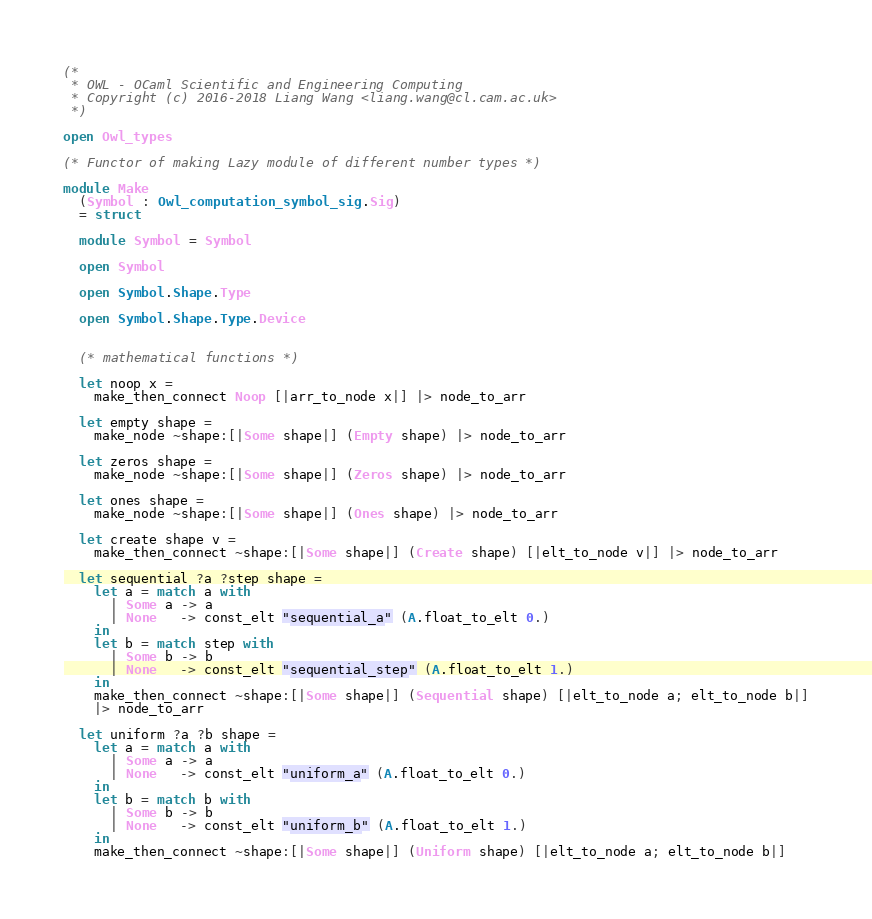<code> <loc_0><loc_0><loc_500><loc_500><_OCaml_>(*
 * OWL - OCaml Scientific and Engineering Computing
 * Copyright (c) 2016-2018 Liang Wang <liang.wang@cl.cam.ac.uk>
 *)

open Owl_types

(* Functor of making Lazy module of different number types *)

module Make
  (Symbol : Owl_computation_symbol_sig.Sig)
  = struct

  module Symbol = Symbol

  open Symbol

  open Symbol.Shape.Type

  open Symbol.Shape.Type.Device


  (* mathematical functions *)

  let noop x =
    make_then_connect Noop [|arr_to_node x|] |> node_to_arr

  let empty shape =
    make_node ~shape:[|Some shape|] (Empty shape) |> node_to_arr

  let zeros shape =
    make_node ~shape:[|Some shape|] (Zeros shape) |> node_to_arr

  let ones shape =
    make_node ~shape:[|Some shape|] (Ones shape) |> node_to_arr

  let create shape v =
    make_then_connect ~shape:[|Some shape|] (Create shape) [|elt_to_node v|] |> node_to_arr

  let sequential ?a ?step shape =
    let a = match a with
      | Some a -> a
      | None   -> const_elt "sequential_a" (A.float_to_elt 0.)
    in
    let b = match step with
      | Some b -> b
      | None   -> const_elt "sequential_step" (A.float_to_elt 1.)
    in
    make_then_connect ~shape:[|Some shape|] (Sequential shape) [|elt_to_node a; elt_to_node b|]
    |> node_to_arr

  let uniform ?a ?b shape =
    let a = match a with
      | Some a -> a
      | None   -> const_elt "uniform_a" (A.float_to_elt 0.)
    in
    let b = match b with
      | Some b -> b
      | None   -> const_elt "uniform_b" (A.float_to_elt 1.)
    in
    make_then_connect ~shape:[|Some shape|] (Uniform shape) [|elt_to_node a; elt_to_node b|]</code> 